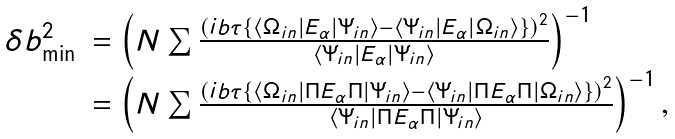<formula> <loc_0><loc_0><loc_500><loc_500>\begin{array} { l l } \delta b _ { \min } ^ { 2 } & = \left ( N \sum \frac { \left ( i b \tau \left \{ \left \langle \Omega _ { i n } \right | E _ { \alpha } \left | \Psi _ { i n } \right \rangle - \left \langle \Psi _ { i n } \right | E _ { \alpha } \left | \Omega _ { i n } \right \rangle \right \} \right ) ^ { 2 } } { \left \langle \Psi _ { i n } \right | E _ { \alpha } \left | \Psi _ { i n } \right \rangle } \right ) ^ { - 1 } \\ & = \left ( { N \sum \frac { \left ( i b \tau \left \{ \left \langle \Omega _ { i n } \right | \Pi E _ { \alpha } \Pi \left | \Psi _ { i n } \right \rangle - \left \langle \Psi _ { i n } \right | \Pi E _ { \alpha } \Pi \left | \Omega _ { i n } \right \rangle \right \} \right ) ^ { 2 } } { \left \langle \Psi _ { i n } \right | \Pi E _ { \alpha } \Pi \left | \Psi _ { i n } \right \rangle } } \right ) ^ { - 1 } , \end{array}</formula> 